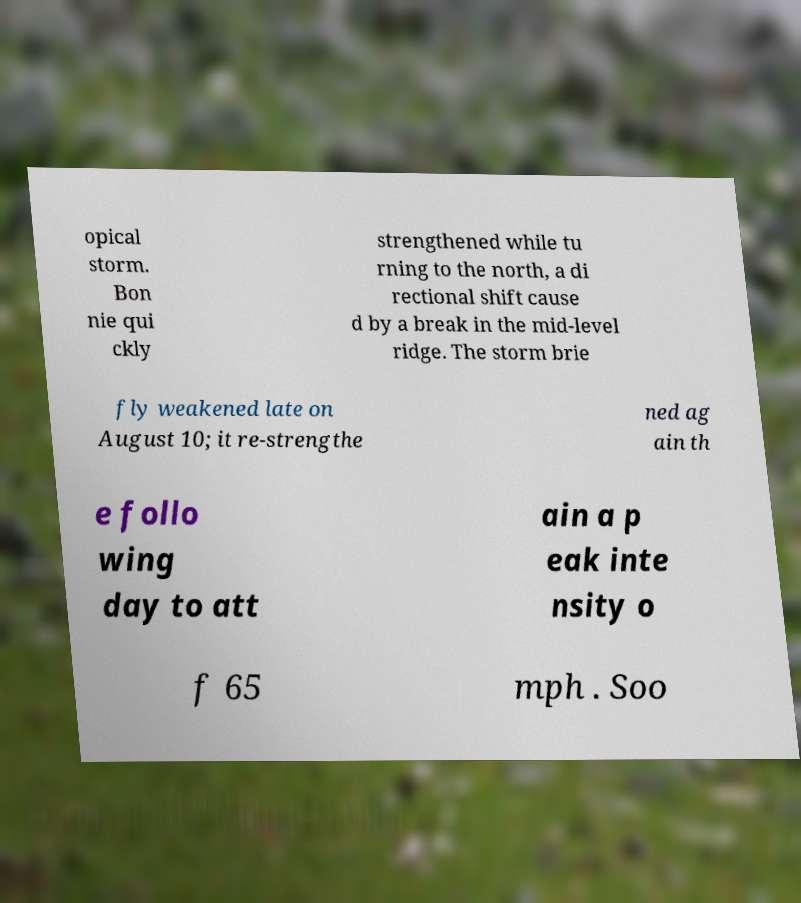Could you assist in decoding the text presented in this image and type it out clearly? opical storm. Bon nie qui ckly strengthened while tu rning to the north, a di rectional shift cause d by a break in the mid-level ridge. The storm brie fly weakened late on August 10; it re-strengthe ned ag ain th e follo wing day to att ain a p eak inte nsity o f 65 mph . Soo 